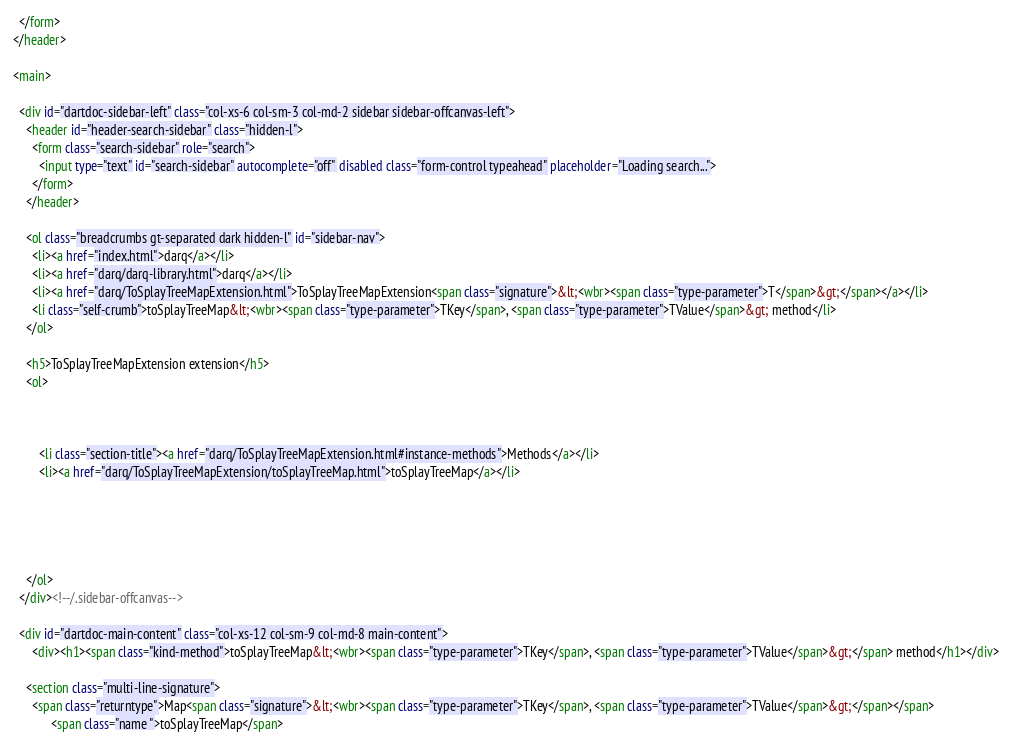Convert code to text. <code><loc_0><loc_0><loc_500><loc_500><_HTML_>  </form>
</header>

<main>

  <div id="dartdoc-sidebar-left" class="col-xs-6 col-sm-3 col-md-2 sidebar sidebar-offcanvas-left">
    <header id="header-search-sidebar" class="hidden-l">
      <form class="search-sidebar" role="search">
        <input type="text" id="search-sidebar" autocomplete="off" disabled class="form-control typeahead" placeholder="Loading search...">
      </form>
    </header>
    
    <ol class="breadcrumbs gt-separated dark hidden-l" id="sidebar-nav">
      <li><a href="index.html">darq</a></li>
      <li><a href="darq/darq-library.html">darq</a></li>
      <li><a href="darq/ToSplayTreeMapExtension.html">ToSplayTreeMapExtension<span class="signature">&lt;<wbr><span class="type-parameter">T</span>&gt;</span></a></li>
      <li class="self-crumb">toSplayTreeMap&lt;<wbr><span class="type-parameter">TKey</span>, <span class="type-parameter">TValue</span>&gt; method</li>
    </ol>
    
    <h5>ToSplayTreeMapExtension extension</h5>
    <ol>
    
    
    
        <li class="section-title"><a href="darq/ToSplayTreeMapExtension.html#instance-methods">Methods</a></li>
        <li><a href="darq/ToSplayTreeMapExtension/toSplayTreeMap.html">toSplayTreeMap</a></li>
    
    
    
    
    
    </ol>
  </div><!--/.sidebar-offcanvas-->

  <div id="dartdoc-main-content" class="col-xs-12 col-sm-9 col-md-8 main-content">
      <div><h1><span class="kind-method">toSplayTreeMap&lt;<wbr><span class="type-parameter">TKey</span>, <span class="type-parameter">TValue</span>&gt;</span> method</h1></div>

    <section class="multi-line-signature">
      <span class="returntype">Map<span class="signature">&lt;<wbr><span class="type-parameter">TKey</span>, <span class="type-parameter">TValue</span>&gt;</span></span>
            <span class="name ">toSplayTreeMap</span></code> 